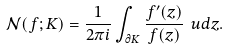<formula> <loc_0><loc_0><loc_500><loc_500>\mathcal { N } ( f ; K ) = \frac { 1 } { 2 \pi i } \int _ { \partial K } \frac { f ^ { \prime } ( z ) } { f ( z ) } \ u d z .</formula> 